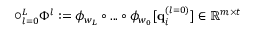Convert formula to latex. <formula><loc_0><loc_0><loc_500><loc_500>\bigcirc _ { l = 0 } ^ { L } \Phi ^ { l } \colon = \phi _ { w _ { L } } \circ \dots \circ \phi _ { w _ { 0 } } [ q _ { i } ^ { ( l = 0 ) } ] \in \mathbb { R } ^ { m \times t }</formula> 